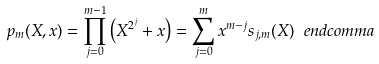Convert formula to latex. <formula><loc_0><loc_0><loc_500><loc_500>p _ { m } ( X , x ) = \prod _ { j = 0 } ^ { m - 1 } \left ( X ^ { 2 ^ { j } } + x \right ) = \sum _ { j = 0 } ^ { m } x ^ { m - j } s _ { j , m } ( X ) \ e n d c o m m a</formula> 